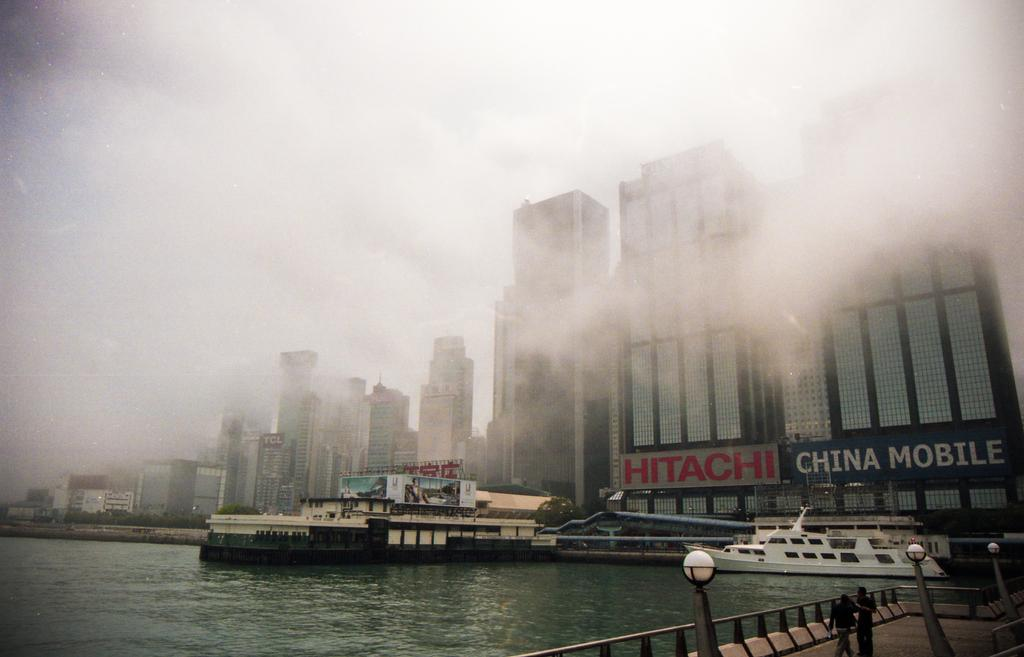What is in the water in the image? There are boats in the water. What structures can be seen in the background? There are buildings visible in the image. What type of lighting is present in the image? Street lights are present. Can you describe the people in the image? Two people are on a path. How many blades can be seen on the boats in the image? There are no blades mentioned in the facts provided, and the boats in the image do not have blades. What type of frogs can be seen hopping near the buildings in the image? There are no frogs mentioned in the facts provided, and no frogs are visible in the image. 